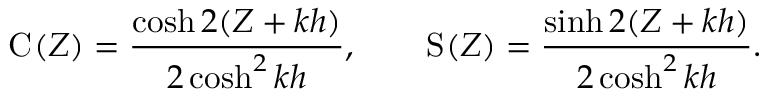Convert formula to latex. <formula><loc_0><loc_0><loc_500><loc_500>C ( Z ) = \frac { \cosh 2 ( Z + k h ) } { 2 \cosh ^ { 2 } k h } , \quad S ( Z ) = \frac { \sinh 2 ( Z + k h ) } { 2 \cosh ^ { 2 } k h } .</formula> 